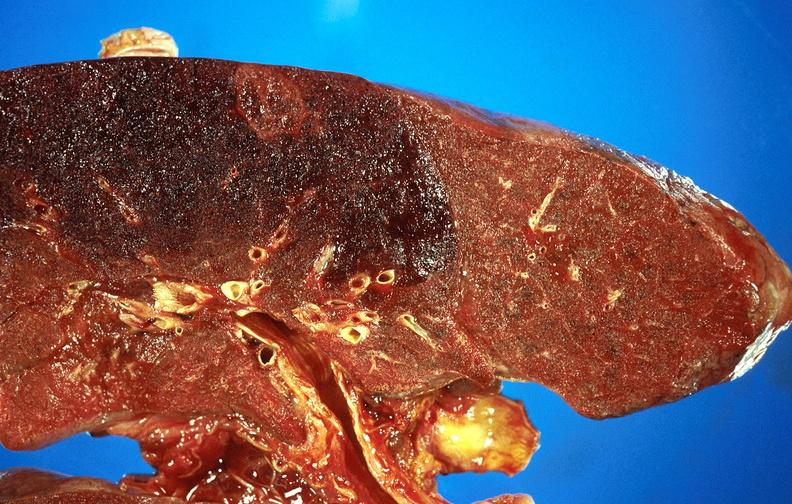s respiratory present?
Answer the question using a single word or phrase. Yes 